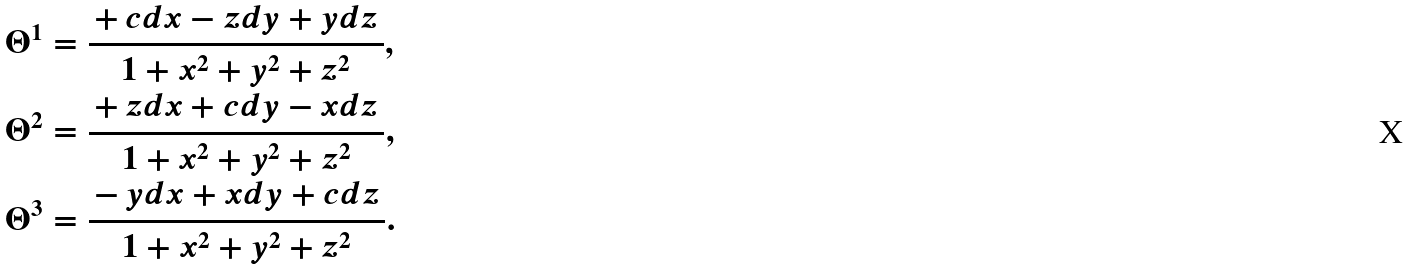Convert formula to latex. <formula><loc_0><loc_0><loc_500><loc_500>\Theta ^ { 1 } & = \frac { \, + \, c d x - z d y + y d z \, } { 1 + x ^ { 2 } + y ^ { 2 } + z ^ { 2 } } , \\ \Theta ^ { 2 } & = \frac { \, + \, z d x + c d y - x d z \, } { 1 + x ^ { 2 } + y ^ { 2 } + z ^ { 2 } } , \\ \Theta ^ { 3 } & = \frac { \, - \, y d x + x d y + c d z \, } { 1 + x ^ { 2 } + y ^ { 2 } + z ^ { 2 } } .</formula> 